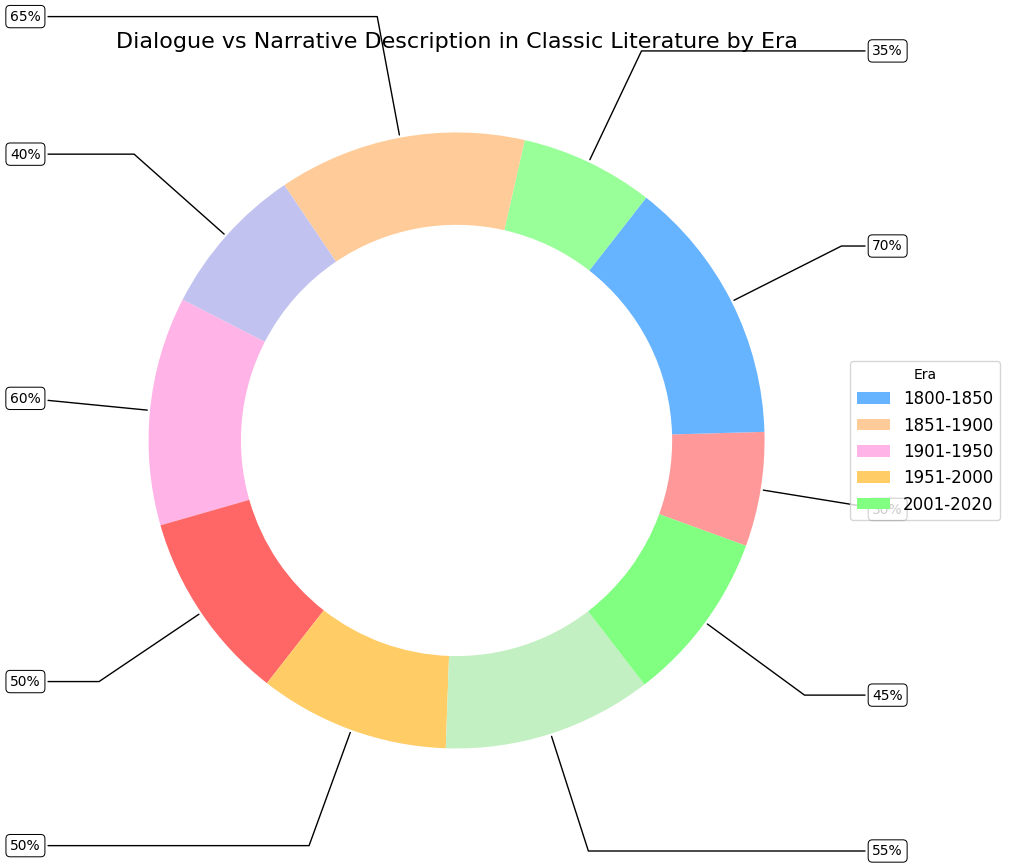Which era has the highest percentage of dialogue? By comparing the dialogue percentages across all eras, the highest value is found in the 2001-2020 era with 55%.
Answer: 2001-2020 Which era has an equal distribution of dialogue and narrative? By looking at the chart, the 1951-2000 era is the only one where the percentages for dialogue and narrative are both 50%.
Answer: 1951-2000 What's the sum of the dialogue percentages for the 19th century (1800-1850 and 1851-1900)? Adding the dialogue percentages for the eras 1800-1850 (30%) and 1851-1900 (35%) gives 30 + 35 = 65%.
Answer: 65% How does the proportion of narrative change from 1800-1850 to 2001-2020? The percentage of narrative in 1800-1850 is 70%, and it decreases to 45% in 2001-2020. The difference is 70% - 45% = 25%.
Answer: Decreases by 25% Between which consecutive eras does the dialogue percentage increase the most? By comparing the dialogue percentage growth between the consecutive eras: 
1800-1850 to 1851-1900 (35%-30% = 5%), 
1851-1900 to 1901-1950 (40%-35% = 5%), 
1901-1950 to 1951-2000 (50%-40% = 10%), 
and 1951-2000 to 2001-2020 (55%-50% = 5%), 
the largest increase of 10% occurs between 1901-1950 and 1951-2000.
Answer: 1901-1950 to 1951-2000 What's the average percentage of narrative description across all eras? Summing the narrative percentages (70% + 65% + 60% + 50% + 45% = 290%) and dividing by the number of eras (5) gives 290/5 = 58%.
Answer: 58% Which era experienced the smallest change in dialogue percentage compared to the previous era? By comparing the changes: 
1800-1850 to 1851-1900 (5%), 
1851-1900 to 1901-1950 (5%), 
1901-1950 to 1951-2000 (10%), 
and 1951-2000 to 2001-2020 (5%), 
the smallest changes of 5% occur in 1800-1850 to 1851-1900, 1851-1900 to 1901-1950, and 1951-2000 to 2001-2020.
Answer: 1800-1850 to 1851-1900, 1851-1900 to 1901-1950, 1951-2000 to 2001-2020 In which era is the combined percentage of dialogue and narrative exactly 100? Since the chart shows only dialogue and narrative, and their percentages sum to 100 in each era, all eras meet this criterion.
Answer: All eras How does the ratio of dialogue to narrative compare between 1800-1850 and 2001-2020? For 1800-1850, the ratio is 30:70, simplified to 3:7. For 2001-2020, the ratio is 55:45, simplified to 11:9.
Answer: 3:7 for 1800-1850, 11:9 for 2001-2020 